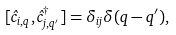<formula> <loc_0><loc_0><loc_500><loc_500>[ { \hat { c } } _ { i , { q } } , { \hat { c } } ^ { \dagger } _ { j , { q } ^ { \prime } } ] = \delta _ { i j } \delta ( { q } - { q } ^ { \prime } ) ,</formula> 